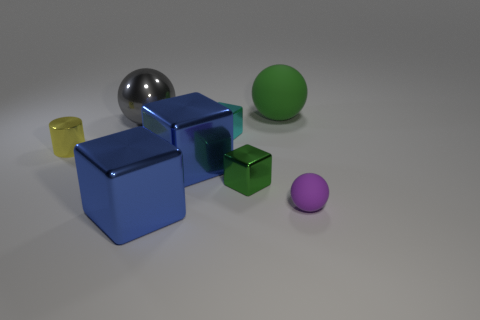What shape is the small metal thing that is the same color as the large matte ball?
Offer a terse response. Cube. What shape is the big green matte object?
Provide a succinct answer. Sphere. Is there any other thing that has the same shape as the tiny yellow metallic object?
Give a very brief answer. No. Is the number of tiny cyan metallic blocks in front of the cyan metallic block less than the number of big red metal spheres?
Provide a short and direct response. No. Does the small metal cube that is in front of the metal cylinder have the same color as the big matte thing?
Your answer should be very brief. Yes. How many matte objects are big gray objects or yellow objects?
Offer a terse response. 0. What color is the sphere that is made of the same material as the small cylinder?
Your response must be concise. Gray. What number of balls are either gray things or large cyan objects?
Offer a very short reply. 1. How many things are tiny rubber balls or tiny objects behind the yellow thing?
Offer a terse response. 2. Is there a large metallic block?
Offer a terse response. Yes. 